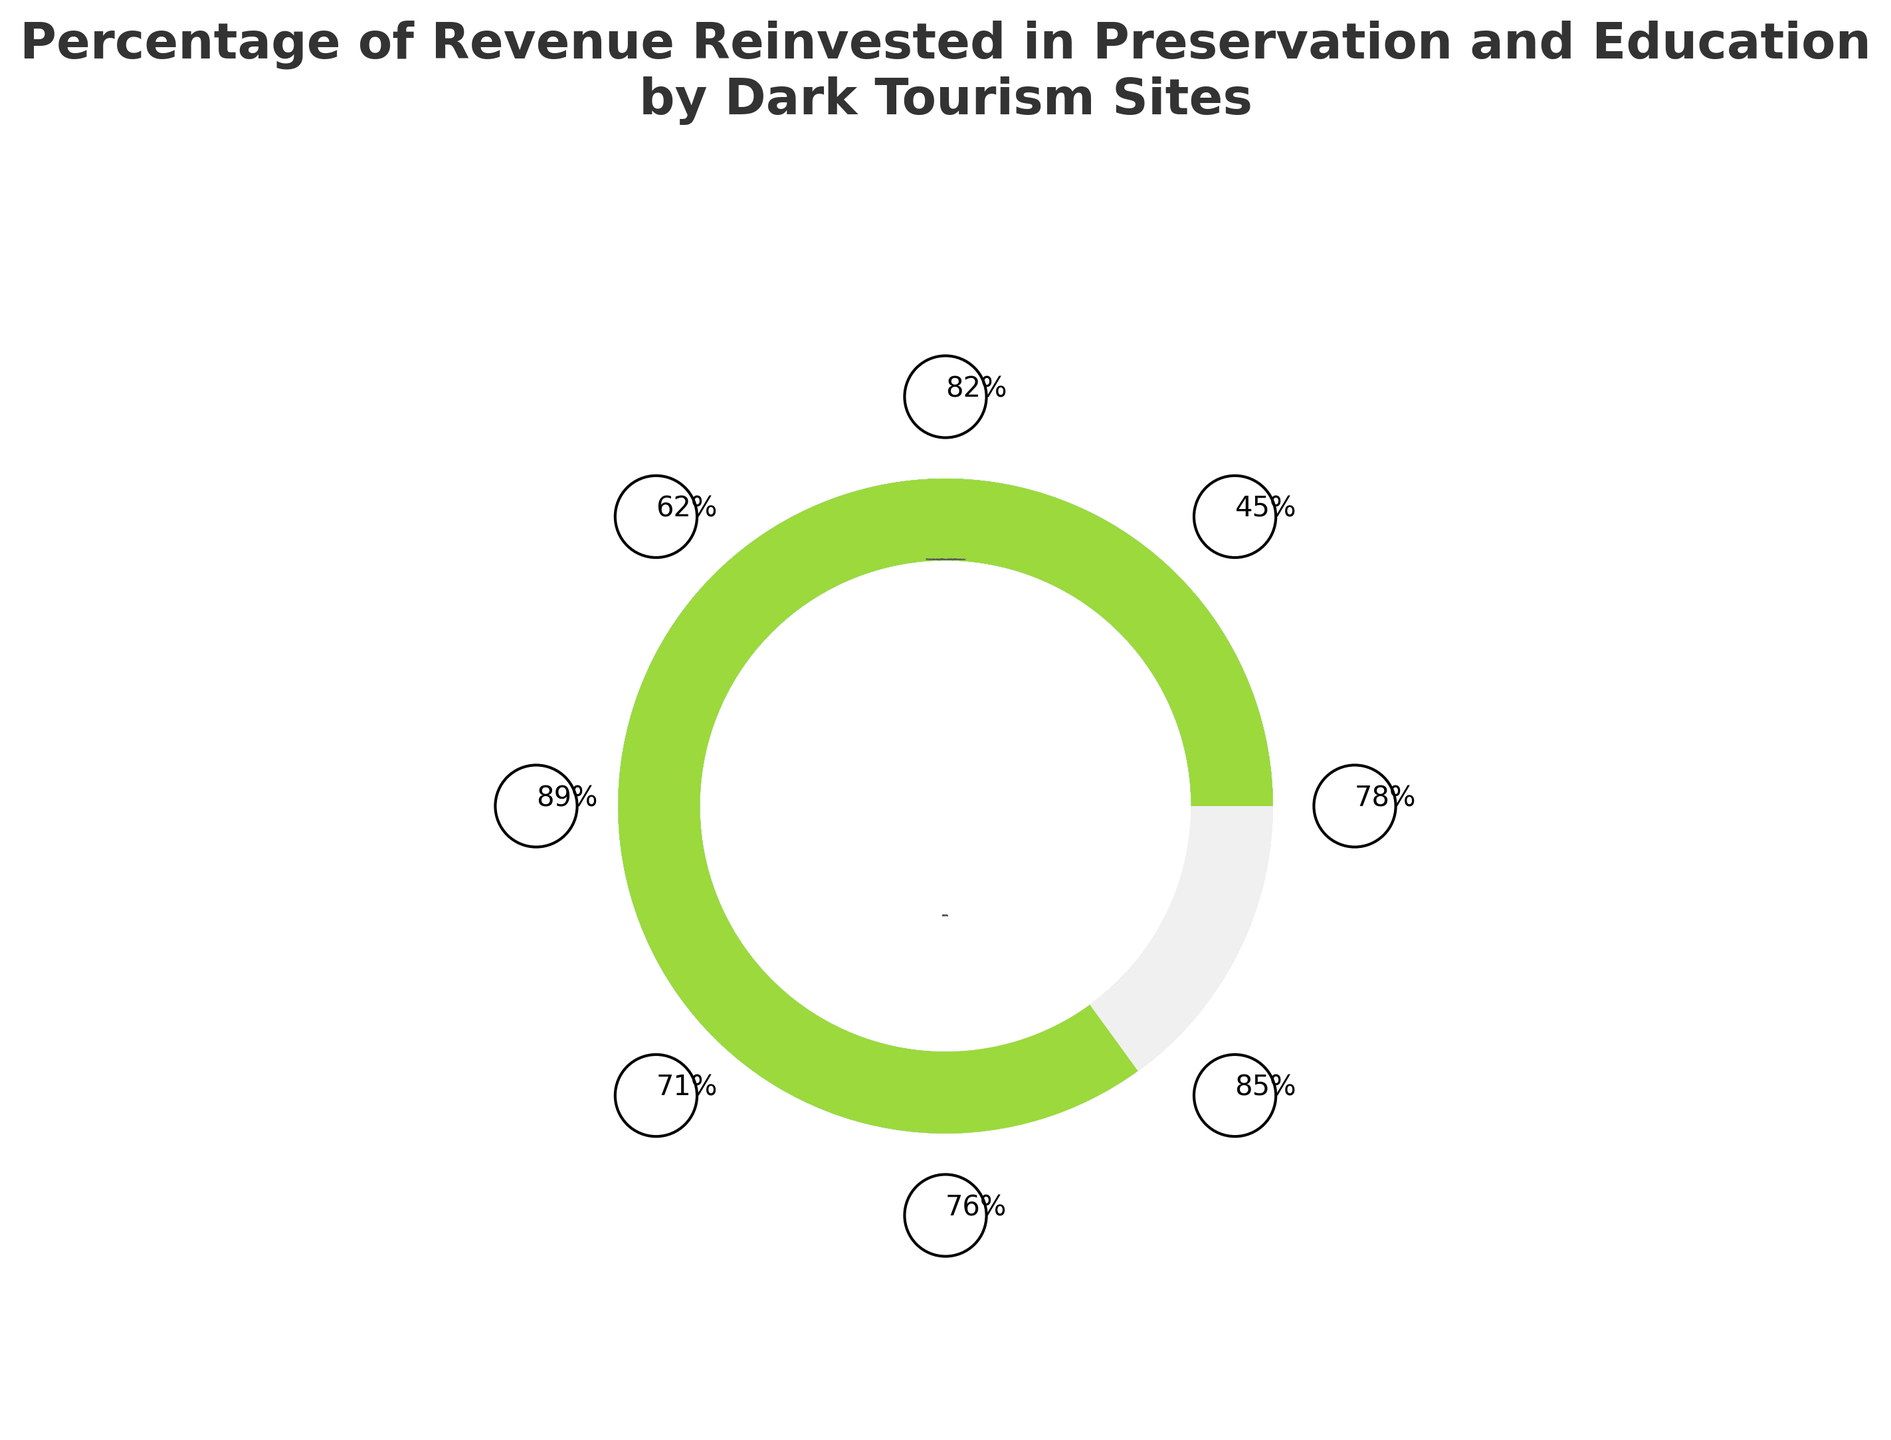What's the title of the figure? The title of the figure is located at the top of the plot and provides a concise summary of what the figure represents. In this case, the title reads "Percentage of Revenue Reinvested in Preservation and Education by Dark Tourism Sites".
Answer: Percentage of Revenue Reinvested in Preservation and Education by Dark Tourism Sites Which dark tourism site reinvests the highest percentage of revenue into preservation and education? By observing the gauge percentages, we see that the Hiroshima Peace Memorial reinvests the highest percentage of its revenue into preservation and education, with a value of 89%.
Answer: Hiroshima Peace Memorial How many dark tourism sites are displayed in the figure? The figure shows individual gauges for each dark tourism site. Counting these gauges, we observe that there are 8 dark tourism sites represented in the figure.
Answer: 8 What is the average percentage of revenue reinvested across all the dark tourism sites? To find the average, sum all the percentages and divide by the number of sites: (78+45+82+62+89+71+76+85) / 8 = 73.5%.
Answer: 73.5% Which site reinvests the least percentage of its revenue into preservation and education, and what is that percentage? By identifying the lowest value among the gauges, we see that the Chernobyl Exclusion Zone reinvests the least percentage of its revenue, with a value of 45%.
Answer: Chernobyl Exclusion Zone, 45% What is the difference in the percentage of revenue reinvested between the Anne Frank House and the Tuol Sleng Genocide Museum? The Anne Frank House reinvests 85% of its revenue, while the Tuol Sleng Genocide Museum reinvests 62%. The difference is 85 - 62 = 23%.
Answer: 23% Compare the reinvestment percentages of Auschwitz-Birkenau Memorial and Alcatraz Island. Which site reinvests more and by how much? Auschwitz-Birkenau Memorial reinvests 78%, and Alcatraz Island reinvests 71%. Auschwitz-Birkenau Memorial reinvests more by 78 - 71 = 7%.
Answer: Auschwitz-Birkenau Memorial, 7% What proportion of the displayed sites reinvest at least 75% of their revenue? To calculate the proportion, count the number of sites reinvesting 75% or more (Auschwitz-Birkenau Memorial, Ground Zero Memorial, Hiroshima Peace Memorial, Pompeii Archaeological Park, Anne Frank House: 5 sites) and divide by the total number of sites (8). The proportion is 5/8 = 0.625 or 62.5%.
Answer: 62.5% Which sites have reinvestment percentages between 60% and 80% inclusive? Observing the figure, the sites with reinvestment percentages within this range are Auschwitz-Birkenau Memorial (78%), Tuol Sleng Genocide Museum (62%), Alcatraz Island (71%), and Pompeii Archaeological Park (76%).
Answer: Auschwitz-Birkenau Memorial, Tuol Sleng Genocide Museum, Alcatraz Island, Pompeii Archaeological Park 